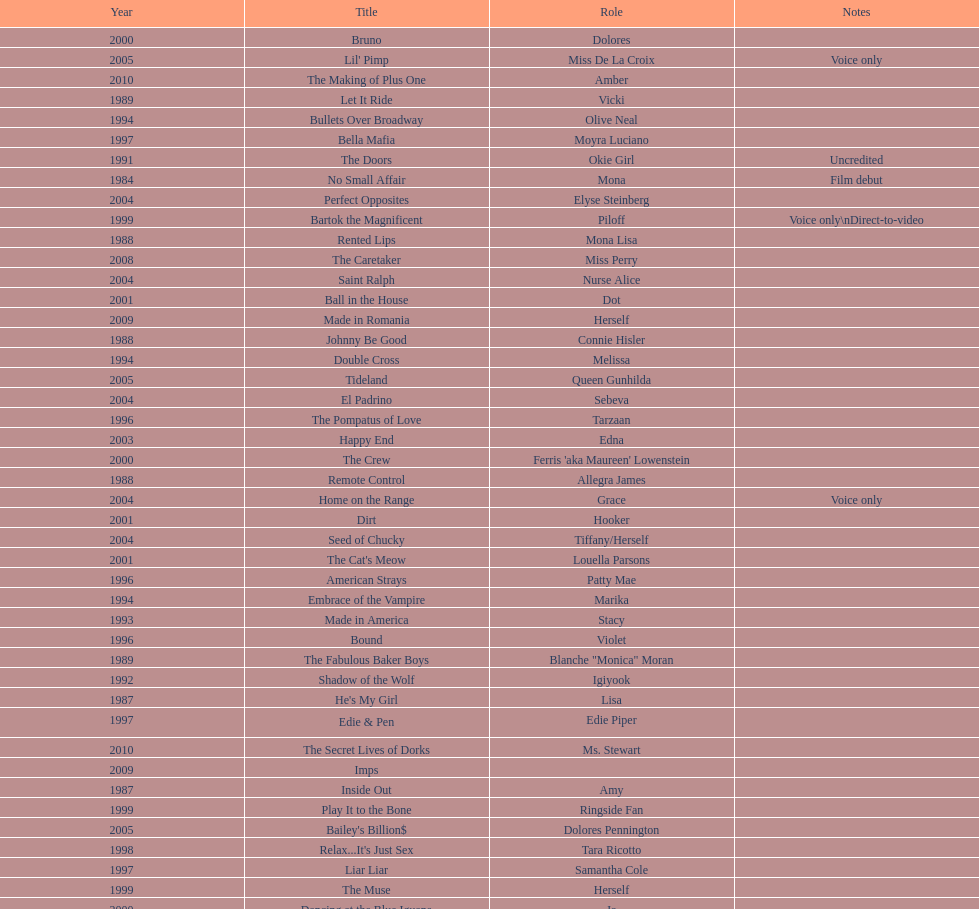Which film aired in 1994 and has marika as the role? Embrace of the Vampire. 